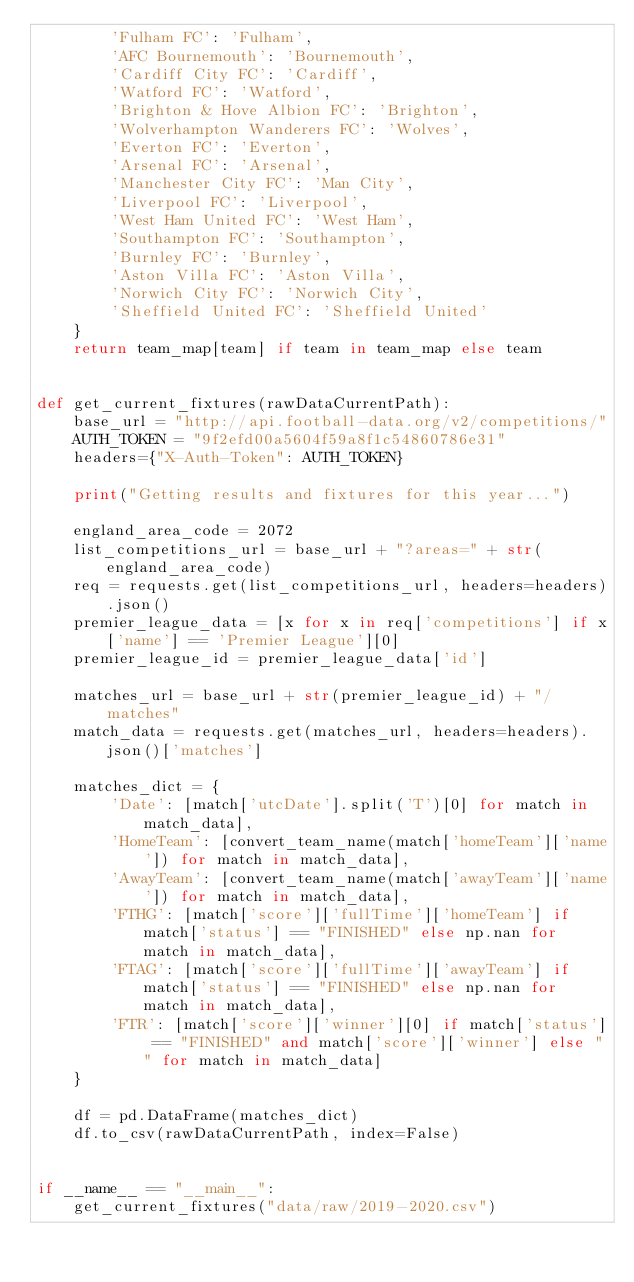<code> <loc_0><loc_0><loc_500><loc_500><_Python_>        'Fulham FC': 'Fulham',
        'AFC Bournemouth': 'Bournemouth',
        'Cardiff City FC': 'Cardiff',
        'Watford FC': 'Watford',
        'Brighton & Hove Albion FC': 'Brighton',
        'Wolverhampton Wanderers FC': 'Wolves',
        'Everton FC': 'Everton',
        'Arsenal FC': 'Arsenal',
        'Manchester City FC': 'Man City',
        'Liverpool FC': 'Liverpool',
        'West Ham United FC': 'West Ham',
        'Southampton FC': 'Southampton',
        'Burnley FC': 'Burnley',
        'Aston Villa FC': 'Aston Villa',
        'Norwich City FC': 'Norwich City',
        'Sheffield United FC': 'Sheffield United'
    }
    return team_map[team] if team in team_map else team


def get_current_fixtures(rawDataCurrentPath):
    base_url = "http://api.football-data.org/v2/competitions/"
    AUTH_TOKEN = "9f2efd00a5604f59a8f1c54860786e31"
    headers={"X-Auth-Token": AUTH_TOKEN}

    print("Getting results and fixtures for this year...")

    england_area_code = 2072
    list_competitions_url = base_url + "?areas=" + str(england_area_code)
    req = requests.get(list_competitions_url, headers=headers).json()
    premier_league_data = [x for x in req['competitions'] if x['name'] == 'Premier League'][0]
    premier_league_id = premier_league_data['id']

    matches_url = base_url + str(premier_league_id) + "/matches"
    match_data = requests.get(matches_url, headers=headers).json()['matches']

    matches_dict = {
        'Date': [match['utcDate'].split('T')[0] for match in match_data],
        'HomeTeam': [convert_team_name(match['homeTeam']['name']) for match in match_data],
        'AwayTeam': [convert_team_name(match['awayTeam']['name']) for match in match_data],
        'FTHG': [match['score']['fullTime']['homeTeam'] if match['status'] == "FINISHED" else np.nan for match in match_data],
        'FTAG': [match['score']['fullTime']['awayTeam'] if match['status'] == "FINISHED" else np.nan for match in match_data],
        'FTR': [match['score']['winner'][0] if match['status'] == "FINISHED" and match['score']['winner'] else "" for match in match_data]
    }

    df = pd.DataFrame(matches_dict)
    df.to_csv(rawDataCurrentPath, index=False)


if __name__ == "__main__":
    get_current_fixtures("data/raw/2019-2020.csv")</code> 